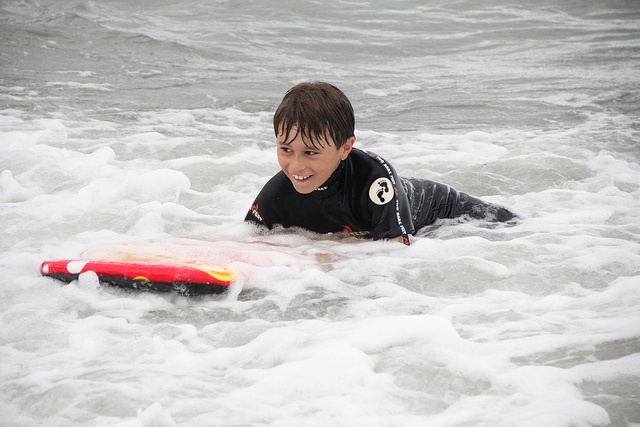Describe the objects in this image and their specific colors. I can see people in gray, black, and salmon tones and surfboard in gray, lightgray, salmon, and red tones in this image. 